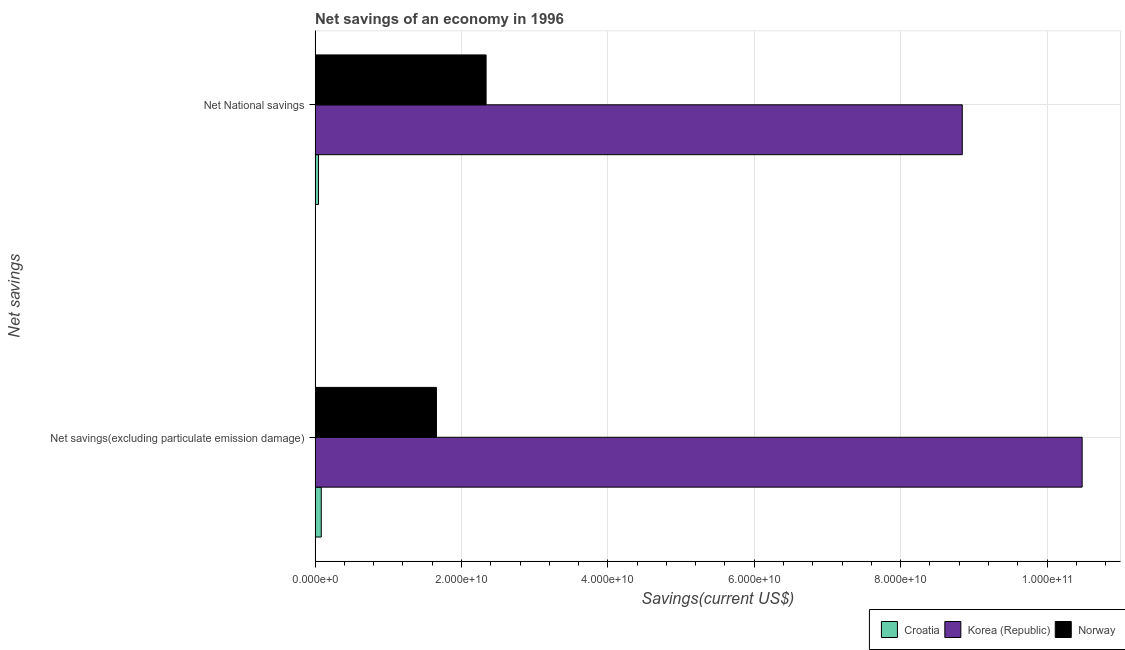Are the number of bars on each tick of the Y-axis equal?
Provide a succinct answer. Yes. How many bars are there on the 2nd tick from the top?
Provide a succinct answer. 3. How many bars are there on the 2nd tick from the bottom?
Your response must be concise. 3. What is the label of the 1st group of bars from the top?
Make the answer very short. Net National savings. What is the net national savings in Korea (Republic)?
Offer a terse response. 8.84e+1. Across all countries, what is the maximum net savings(excluding particulate emission damage)?
Provide a short and direct response. 1.05e+11. Across all countries, what is the minimum net national savings?
Offer a very short reply. 4.67e+08. In which country was the net national savings maximum?
Give a very brief answer. Korea (Republic). In which country was the net national savings minimum?
Your answer should be very brief. Croatia. What is the total net savings(excluding particulate emission damage) in the graph?
Provide a succinct answer. 1.22e+11. What is the difference between the net savings(excluding particulate emission damage) in Korea (Republic) and that in Norway?
Offer a very short reply. 8.82e+1. What is the difference between the net savings(excluding particulate emission damage) in Korea (Republic) and the net national savings in Croatia?
Provide a short and direct response. 1.04e+11. What is the average net national savings per country?
Make the answer very short. 3.74e+1. What is the difference between the net savings(excluding particulate emission damage) and net national savings in Korea (Republic)?
Ensure brevity in your answer.  1.64e+1. In how many countries, is the net savings(excluding particulate emission damage) greater than 68000000000 US$?
Your response must be concise. 1. What is the ratio of the net savings(excluding particulate emission damage) in Korea (Republic) to that in Croatia?
Ensure brevity in your answer.  124.39. In how many countries, is the net savings(excluding particulate emission damage) greater than the average net savings(excluding particulate emission damage) taken over all countries?
Offer a very short reply. 1. How many countries are there in the graph?
Provide a short and direct response. 3. Are the values on the major ticks of X-axis written in scientific E-notation?
Offer a terse response. Yes. Does the graph contain any zero values?
Give a very brief answer. No. Does the graph contain grids?
Offer a terse response. Yes. How are the legend labels stacked?
Your answer should be compact. Horizontal. What is the title of the graph?
Provide a succinct answer. Net savings of an economy in 1996. What is the label or title of the X-axis?
Make the answer very short. Savings(current US$). What is the label or title of the Y-axis?
Offer a terse response. Net savings. What is the Savings(current US$) in Croatia in Net savings(excluding particulate emission damage)?
Your response must be concise. 8.43e+08. What is the Savings(current US$) in Korea (Republic) in Net savings(excluding particulate emission damage)?
Provide a succinct answer. 1.05e+11. What is the Savings(current US$) of Norway in Net savings(excluding particulate emission damage)?
Make the answer very short. 1.66e+1. What is the Savings(current US$) in Croatia in Net National savings?
Provide a succinct answer. 4.67e+08. What is the Savings(current US$) in Korea (Republic) in Net National savings?
Your response must be concise. 8.84e+1. What is the Savings(current US$) in Norway in Net National savings?
Keep it short and to the point. 2.34e+1. Across all Net savings, what is the maximum Savings(current US$) of Croatia?
Give a very brief answer. 8.43e+08. Across all Net savings, what is the maximum Savings(current US$) in Korea (Republic)?
Provide a short and direct response. 1.05e+11. Across all Net savings, what is the maximum Savings(current US$) of Norway?
Provide a succinct answer. 2.34e+1. Across all Net savings, what is the minimum Savings(current US$) of Croatia?
Provide a short and direct response. 4.67e+08. Across all Net savings, what is the minimum Savings(current US$) of Korea (Republic)?
Ensure brevity in your answer.  8.84e+1. Across all Net savings, what is the minimum Savings(current US$) in Norway?
Offer a very short reply. 1.66e+1. What is the total Savings(current US$) in Croatia in the graph?
Give a very brief answer. 1.31e+09. What is the total Savings(current US$) of Korea (Republic) in the graph?
Offer a terse response. 1.93e+11. What is the total Savings(current US$) of Norway in the graph?
Provide a succinct answer. 3.99e+1. What is the difference between the Savings(current US$) of Croatia in Net savings(excluding particulate emission damage) and that in Net National savings?
Provide a short and direct response. 3.76e+08. What is the difference between the Savings(current US$) of Korea (Republic) in Net savings(excluding particulate emission damage) and that in Net National savings?
Ensure brevity in your answer.  1.64e+1. What is the difference between the Savings(current US$) in Norway in Net savings(excluding particulate emission damage) and that in Net National savings?
Keep it short and to the point. -6.78e+09. What is the difference between the Savings(current US$) of Croatia in Net savings(excluding particulate emission damage) and the Savings(current US$) of Korea (Republic) in Net National savings?
Your answer should be very brief. -8.76e+1. What is the difference between the Savings(current US$) of Croatia in Net savings(excluding particulate emission damage) and the Savings(current US$) of Norway in Net National savings?
Keep it short and to the point. -2.25e+1. What is the difference between the Savings(current US$) in Korea (Republic) in Net savings(excluding particulate emission damage) and the Savings(current US$) in Norway in Net National savings?
Ensure brevity in your answer.  8.14e+1. What is the average Savings(current US$) in Croatia per Net savings?
Offer a terse response. 6.55e+08. What is the average Savings(current US$) in Korea (Republic) per Net savings?
Keep it short and to the point. 9.66e+1. What is the average Savings(current US$) in Norway per Net savings?
Your response must be concise. 2.00e+1. What is the difference between the Savings(current US$) in Croatia and Savings(current US$) in Korea (Republic) in Net savings(excluding particulate emission damage)?
Provide a short and direct response. -1.04e+11. What is the difference between the Savings(current US$) in Croatia and Savings(current US$) in Norway in Net savings(excluding particulate emission damage)?
Your answer should be very brief. -1.57e+1. What is the difference between the Savings(current US$) in Korea (Republic) and Savings(current US$) in Norway in Net savings(excluding particulate emission damage)?
Offer a terse response. 8.82e+1. What is the difference between the Savings(current US$) in Croatia and Savings(current US$) in Korea (Republic) in Net National savings?
Keep it short and to the point. -8.80e+1. What is the difference between the Savings(current US$) of Croatia and Savings(current US$) of Norway in Net National savings?
Ensure brevity in your answer.  -2.29e+1. What is the difference between the Savings(current US$) in Korea (Republic) and Savings(current US$) in Norway in Net National savings?
Offer a terse response. 6.51e+1. What is the ratio of the Savings(current US$) of Croatia in Net savings(excluding particulate emission damage) to that in Net National savings?
Your answer should be very brief. 1.8. What is the ratio of the Savings(current US$) of Korea (Republic) in Net savings(excluding particulate emission damage) to that in Net National savings?
Ensure brevity in your answer.  1.19. What is the ratio of the Savings(current US$) of Norway in Net savings(excluding particulate emission damage) to that in Net National savings?
Your answer should be very brief. 0.71. What is the difference between the highest and the second highest Savings(current US$) in Croatia?
Give a very brief answer. 3.76e+08. What is the difference between the highest and the second highest Savings(current US$) of Korea (Republic)?
Offer a very short reply. 1.64e+1. What is the difference between the highest and the second highest Savings(current US$) in Norway?
Offer a very short reply. 6.78e+09. What is the difference between the highest and the lowest Savings(current US$) in Croatia?
Keep it short and to the point. 3.76e+08. What is the difference between the highest and the lowest Savings(current US$) of Korea (Republic)?
Offer a very short reply. 1.64e+1. What is the difference between the highest and the lowest Savings(current US$) of Norway?
Your response must be concise. 6.78e+09. 